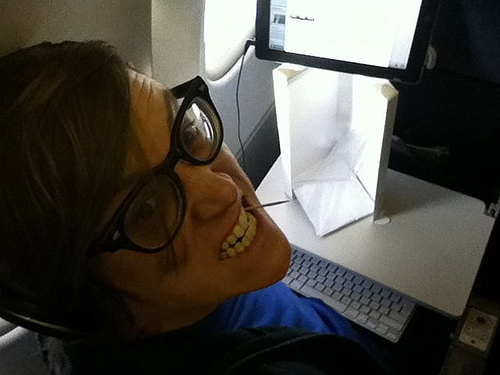Is the table to the left or to the right of the guy? The table is to the right of the guy. 